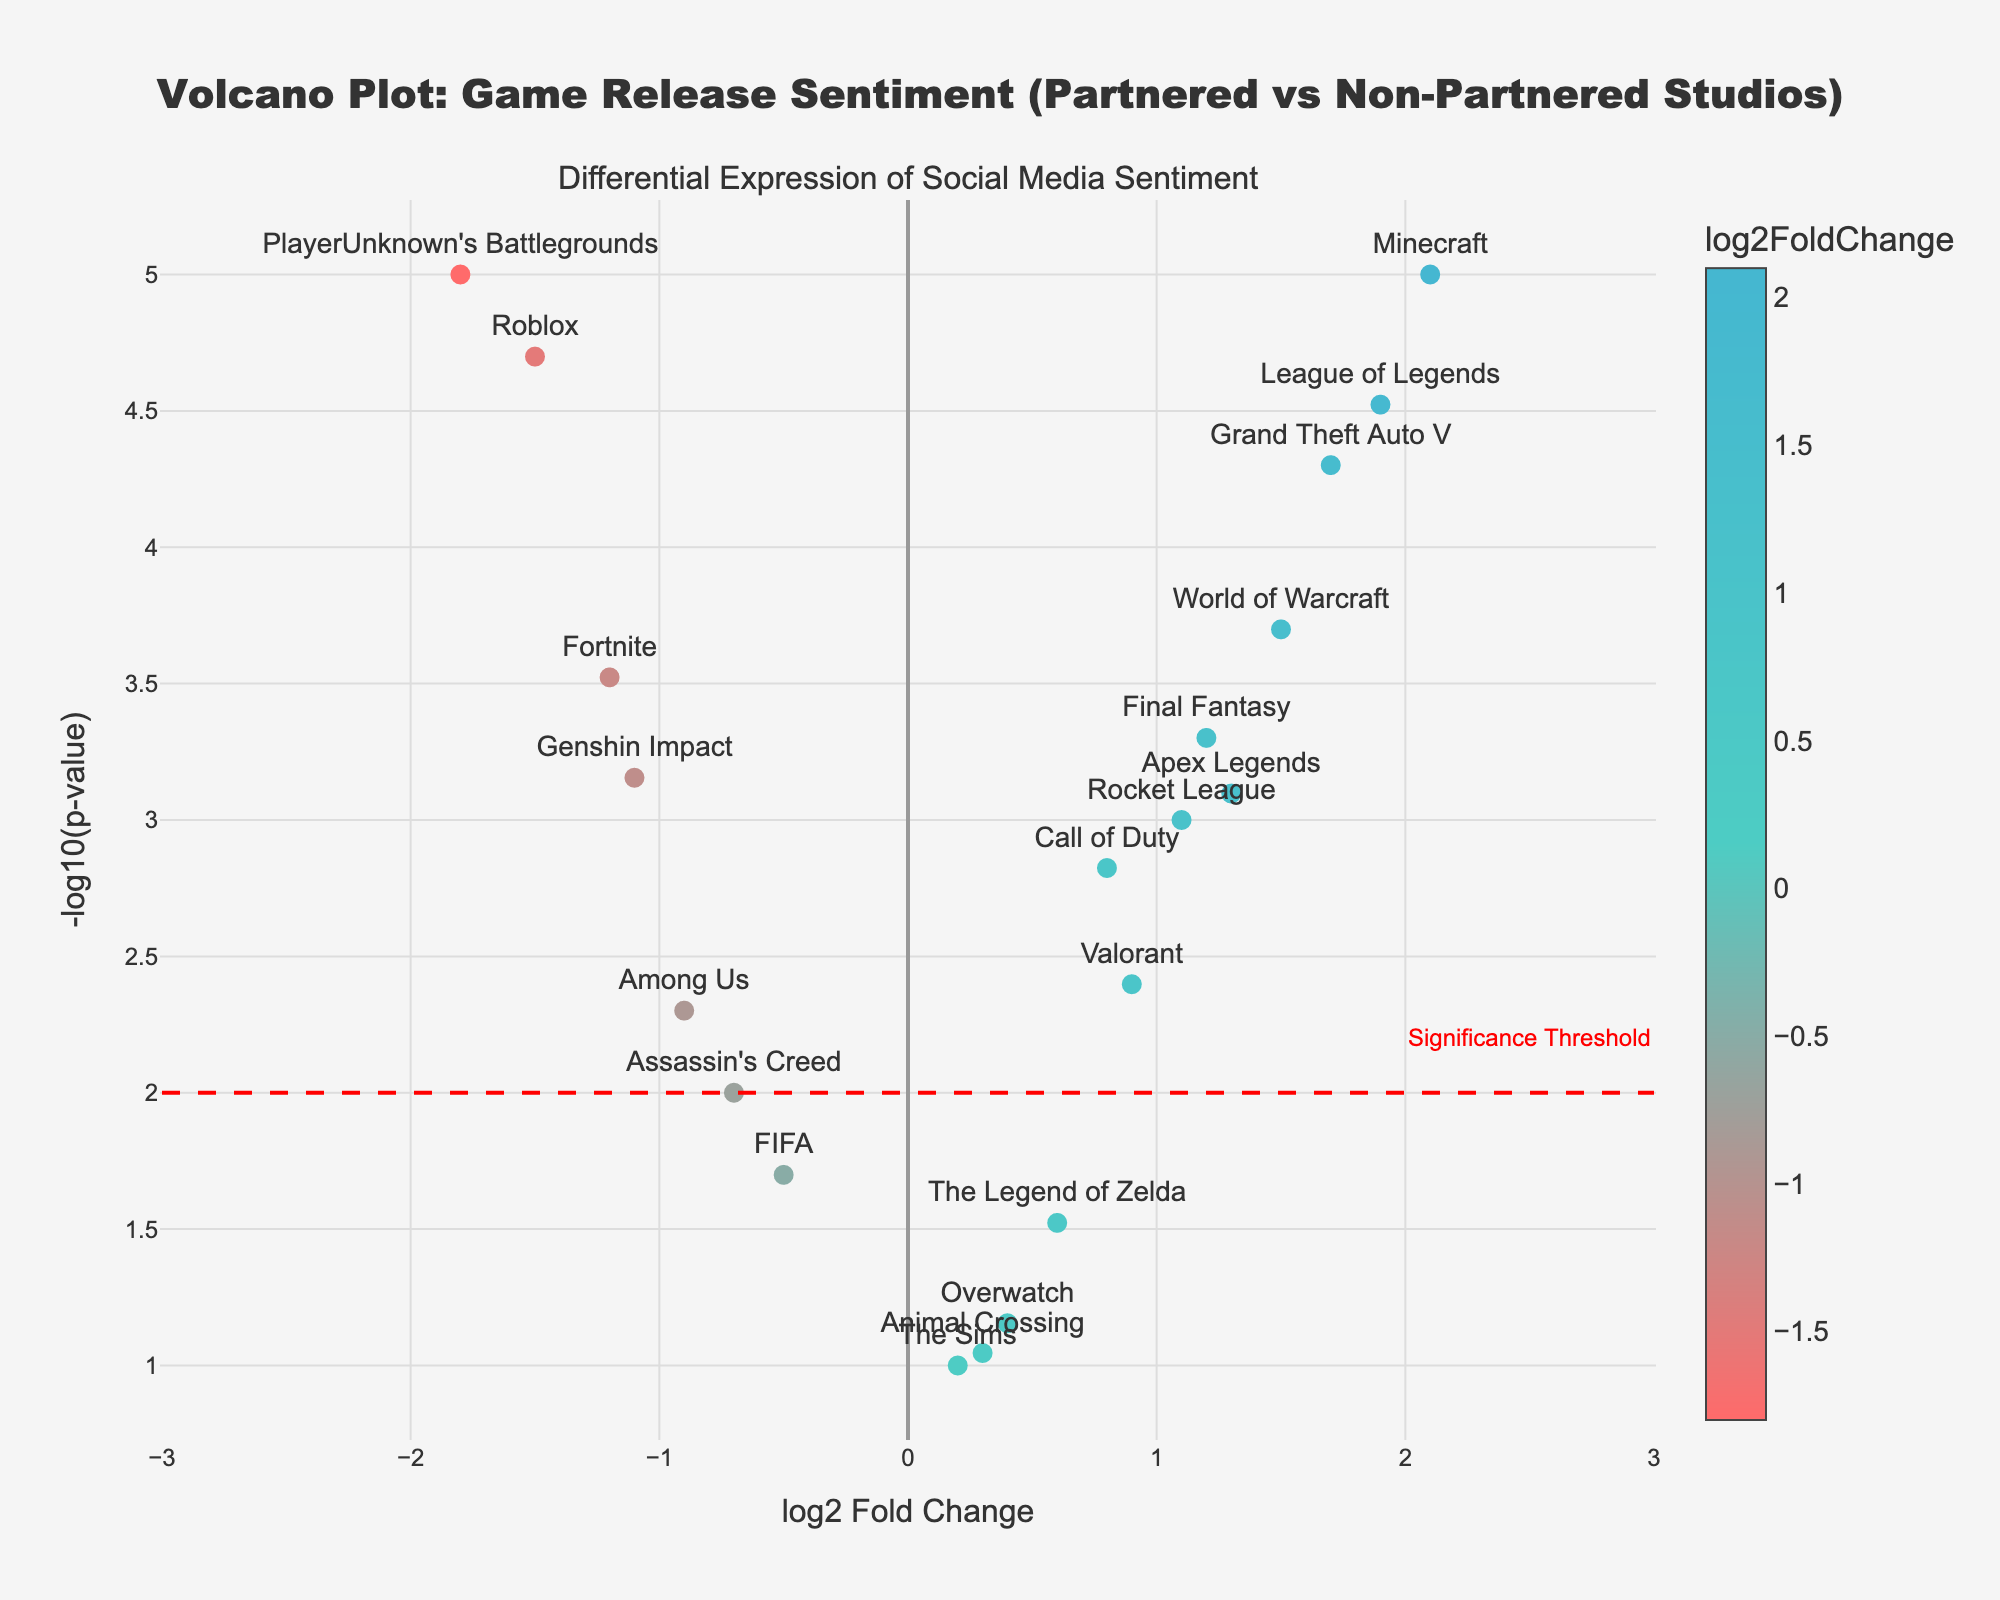What's the title of this plot? The title of the plot is prominently displayed at the top of the figure. It reads "Volcano Plot: Game Release Sentiment (Partnered vs Non-Partnered Studios)." We can read this directly from the plot.
Answer: Volcano Plot: Game Release Sentiment (Partnered vs Non-Partnered Studios) How is statistical significance represented in this plot? In the plot, statistical significance is represented by a dashed red line at -log10(p-value) = 2. An annotation "Significance Threshold" is also placed near this line to indicate its importance.
Answer: Dashed red line at -log10(p-value) = 2 Which game has the highest log2 Fold Change? To determine which game has the highest log2 Fold Change, look for the data point farthest to the right on the x-axis. This game is Minecraft with a log2 Fold Change of 2.1.
Answer: Minecraft Which game has the most negative sentiment log2 Fold Change? To find the game with the most negative sentiment log2 Fold Change, look for the data point farthest to the left on the x-axis. This game is PlayerUnknown's Battlegrounds with a log2 Fold Change of -1.8.
Answer: PlayerUnknown's Battlegrounds How many games are considered statistically significant based on the significance threshold? Games are statistically significant if their -log10(p-value) is above 2. Count the number of points above the red dashed line. There are 14 such points.
Answer: 14 Which games lie closest to the significance threshold? The games closest to the significance threshold will have -log10(p-value) just above 2. These games are Genshin Impact, Valorant, and Final Fantasy.
Answer: Genshin Impact, Valorant, Final Fantasy What does the color scale in the plot represent? The color scale in the plot is associated with the log2 Fold Change, as indicated by the color bar on the right side of the plot. It changes from negative colors (e.g., red) to positive colors (e.g., blue), which helps visualize the log2 Fold Change direction and magnitude for each game.
Answer: log2 Fold Change Which game has the highest statistical significance for a positive sentiment log2 Fold Change? The highest statistical significance corresponds to the highest -log10(p-value). For a positive log2 Fold Change, Minecraft has the highest significance with a -log10(p-value) around 5.
Answer: Minecraft What is the range of the log2 Fold Change values for the games? To determine the range, identify the minimum and maximum values for log2 Fold Change on the x-axis. The minimum value is approximately -1.8 (PlayerUnknown's Battlegrounds), and the maximum value is approximately 2.1 (Minecraft). Thus, the range is from -1.8 to 2.1.
Answer: -1.8 to 2.1 